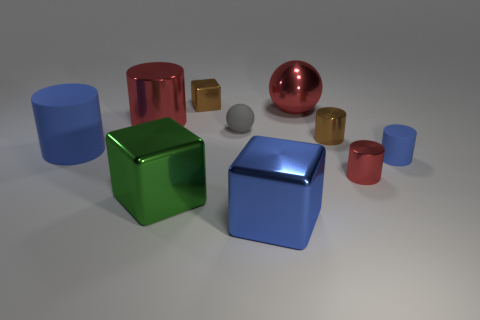Are there more tiny brown metal objects that are in front of the small matte cylinder than small spheres that are on the right side of the big sphere?
Offer a terse response. No. How big is the blue rubber cylinder on the left side of the matte cylinder that is to the right of the big metallic object on the left side of the green metallic cube?
Offer a terse response. Large. Is there a block that has the same color as the matte sphere?
Offer a terse response. No. How many big cyan metallic balls are there?
Keep it short and to the point. 0. What material is the big blue thing in front of the big cylinder in front of the tiny matte thing behind the brown cylinder made of?
Ensure brevity in your answer.  Metal. Are there any large red objects made of the same material as the green object?
Give a very brief answer. Yes. Is the small gray object made of the same material as the big ball?
Ensure brevity in your answer.  No. How many cubes are small purple metallic things or small gray objects?
Your answer should be compact. 0. What color is the other tiny cylinder that is made of the same material as the brown cylinder?
Provide a succinct answer. Red. Is the number of large red balls less than the number of metal objects?
Offer a terse response. Yes. 